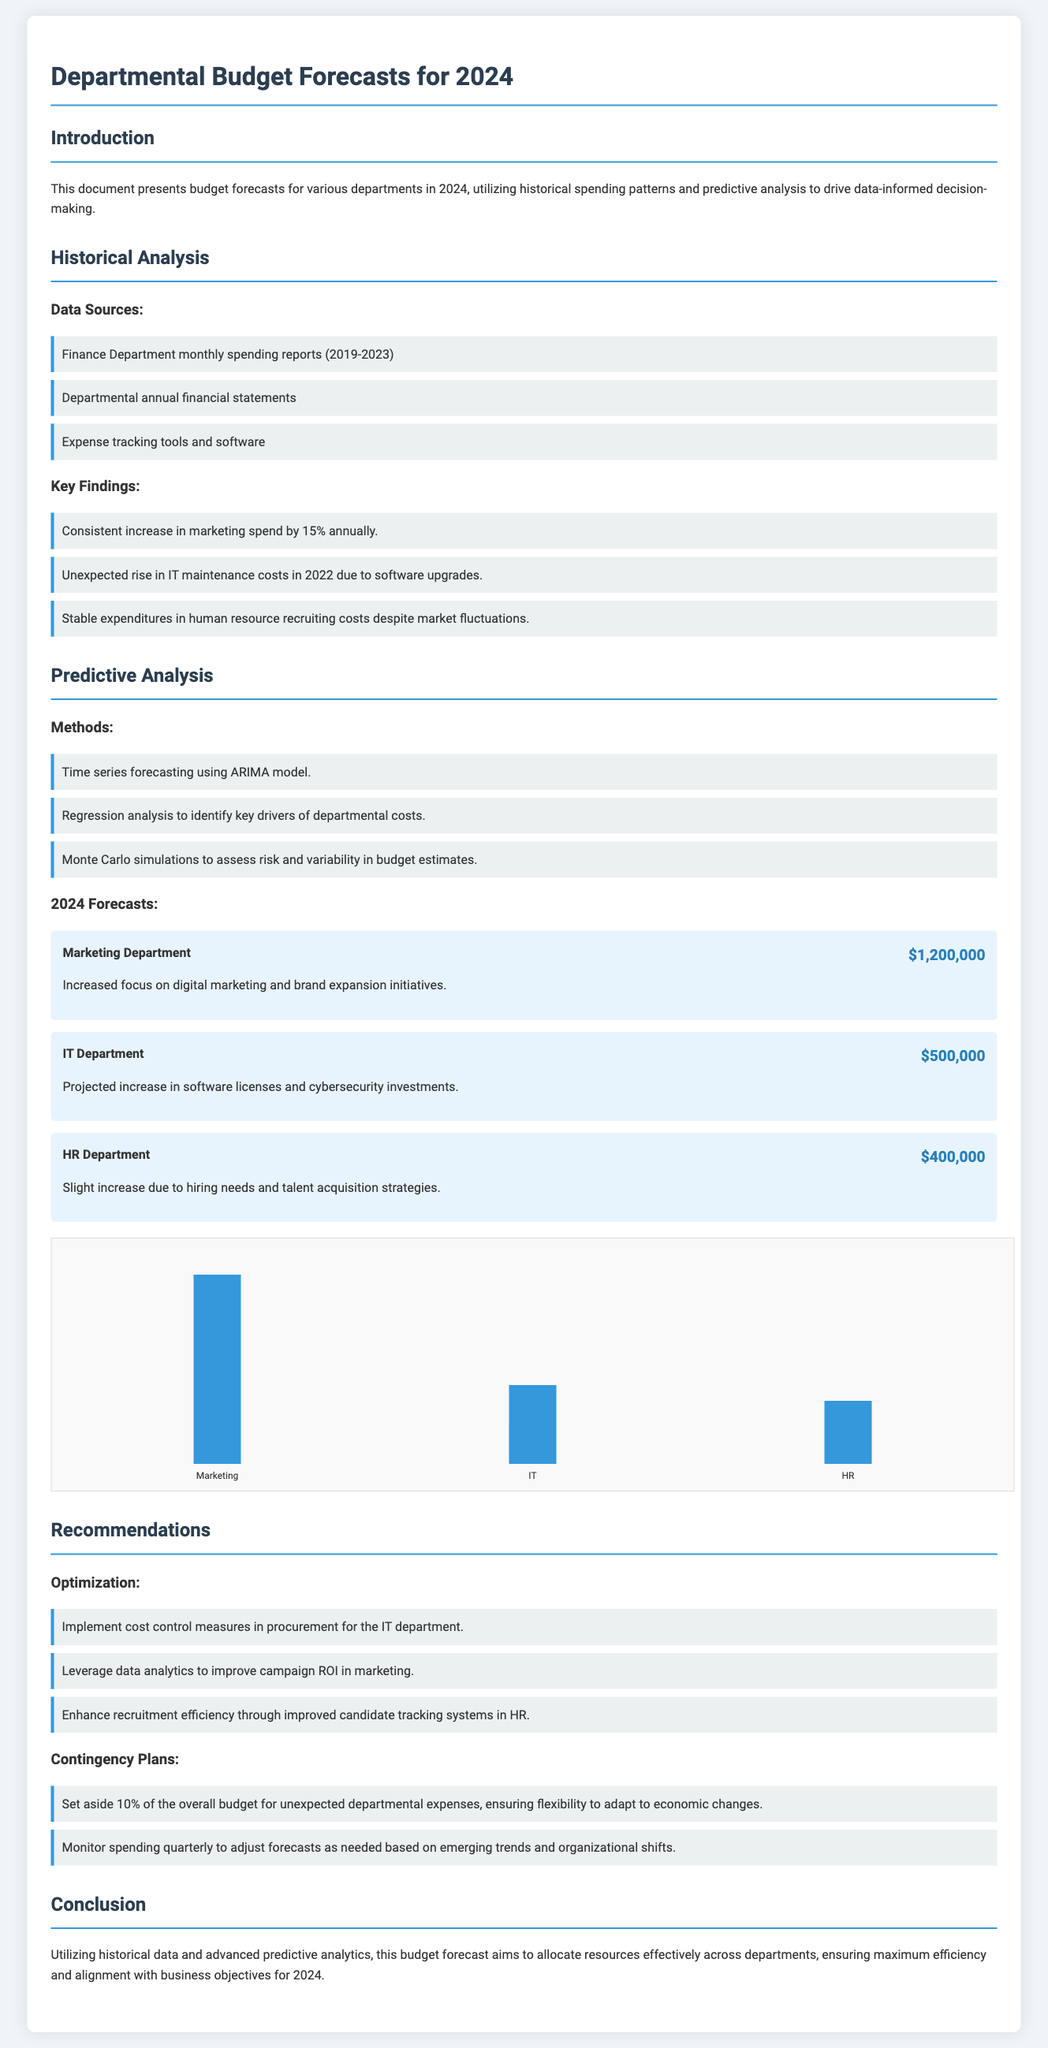What is the total forecast for the Marketing Department? The forecast for the Marketing Department is presented clearly as part of the budget forecasts in the document.
Answer: $1,200,000 What are the key drivers of departmental costs identified in the document? The document lists specific methods of analysis used to determine the budget, leading to an understanding of cost drivers.
Answer: Regression analysis What was the percentage increase in marketing spend annually? The historical analysis section identifies specific trends within departmental spending, including marketing.
Answer: 15% What amount is allocated to the IT Department for 2024? The document explicitly states the forecasted budget for the IT Department within the budget forecasts.
Answer: $500,000 What contingency plan percentage is suggested for unexpected departmental expenses? The recommendations section outlines plans to manage budgets that includes specific details on financial preparedness.
Answer: 10% Which method of analysis was used for time series forecasting? The predictive analysis section details the specific methods employed to forecast departmental budgets.
Answer: ARIMA model What is the trend for HR Department recruiting costs? The historical analysis identifies stable spending in specific areas, including HR costs.
Answer: Stable expenditures What is the total budget allocated to the HR Department for 2024? The forecast for the HR Department is stated clearly, showing anticipated financial needs for the upcoming year.
Answer: $400,000 